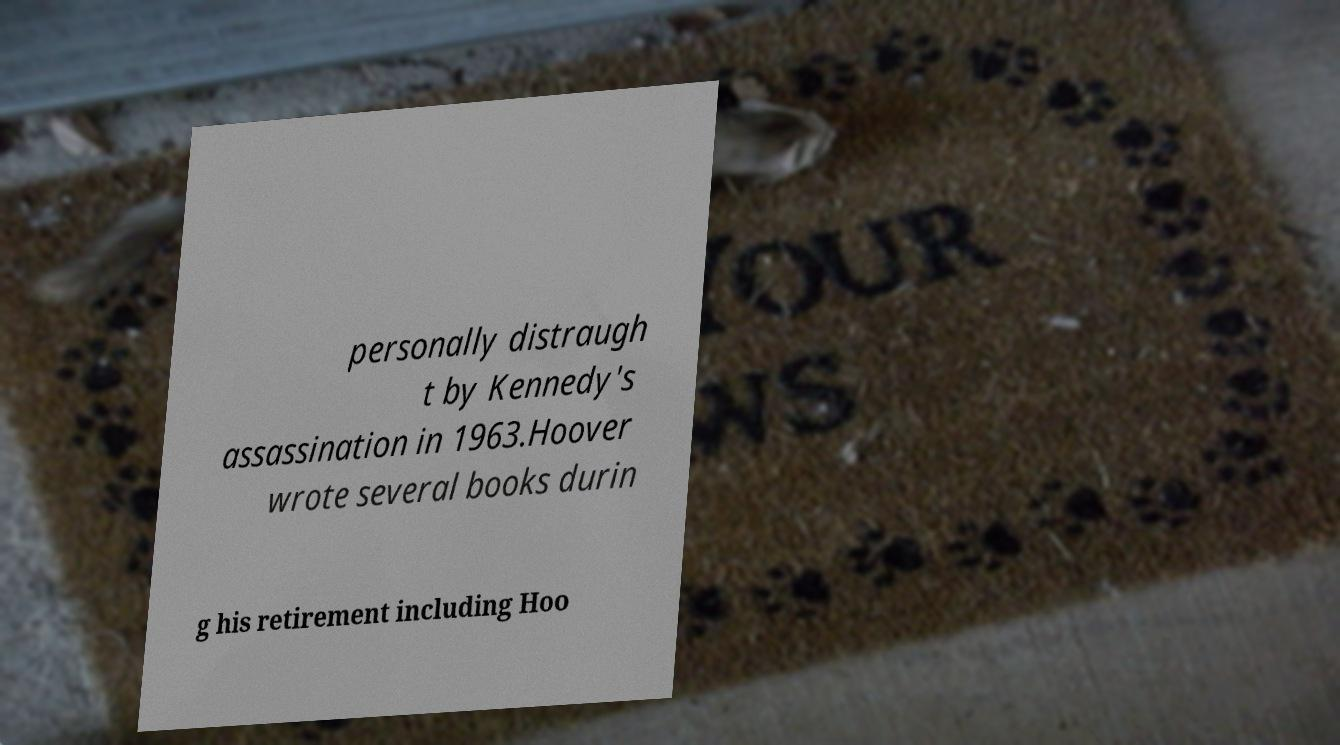Could you extract and type out the text from this image? personally distraugh t by Kennedy's assassination in 1963.Hoover wrote several books durin g his retirement including Hoo 